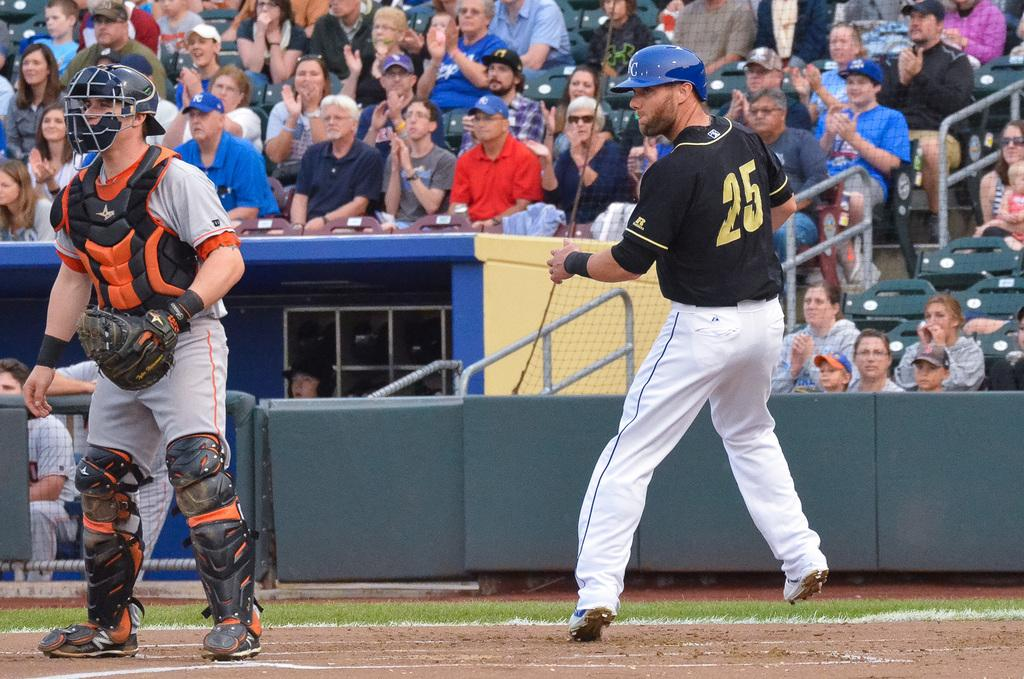<image>
Offer a succinct explanation of the picture presented. a person with the number 25 on the back of the jersey 